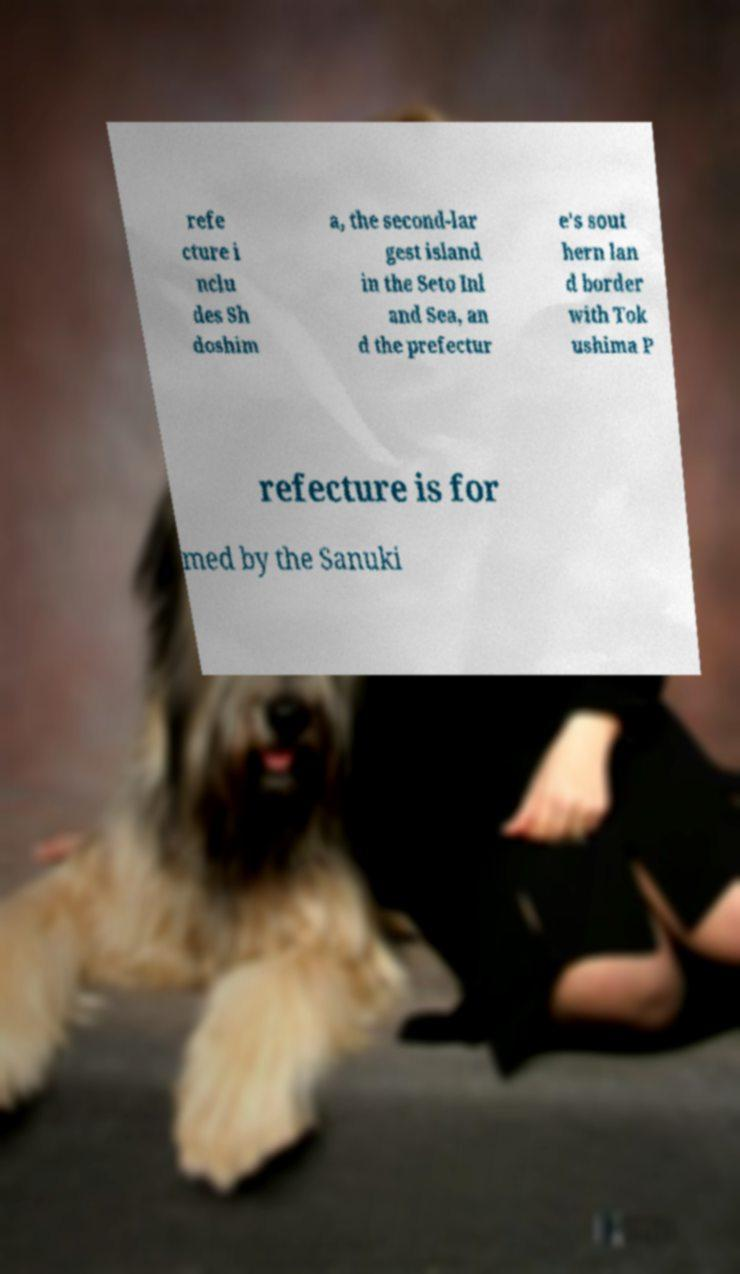Could you extract and type out the text from this image? refe cture i nclu des Sh doshim a, the second-lar gest island in the Seto Inl and Sea, an d the prefectur e's sout hern lan d border with Tok ushima P refecture is for med by the Sanuki 